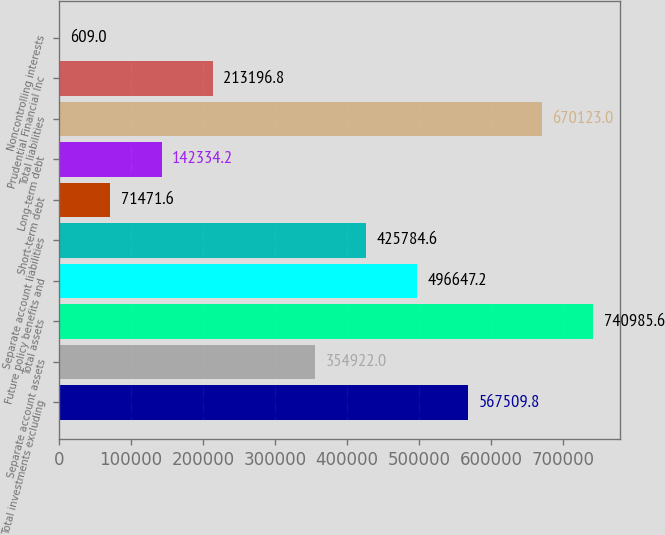Convert chart. <chart><loc_0><loc_0><loc_500><loc_500><bar_chart><fcel>Total investments excluding<fcel>Separate account assets<fcel>Total assets<fcel>Future policy benefits and<fcel>Separate account liabilities<fcel>Short-term debt<fcel>Long-term debt<fcel>Total liabilities<fcel>Prudential Financial Inc<fcel>Noncontrolling interests<nl><fcel>567510<fcel>354922<fcel>740986<fcel>496647<fcel>425785<fcel>71471.6<fcel>142334<fcel>670123<fcel>213197<fcel>609<nl></chart> 